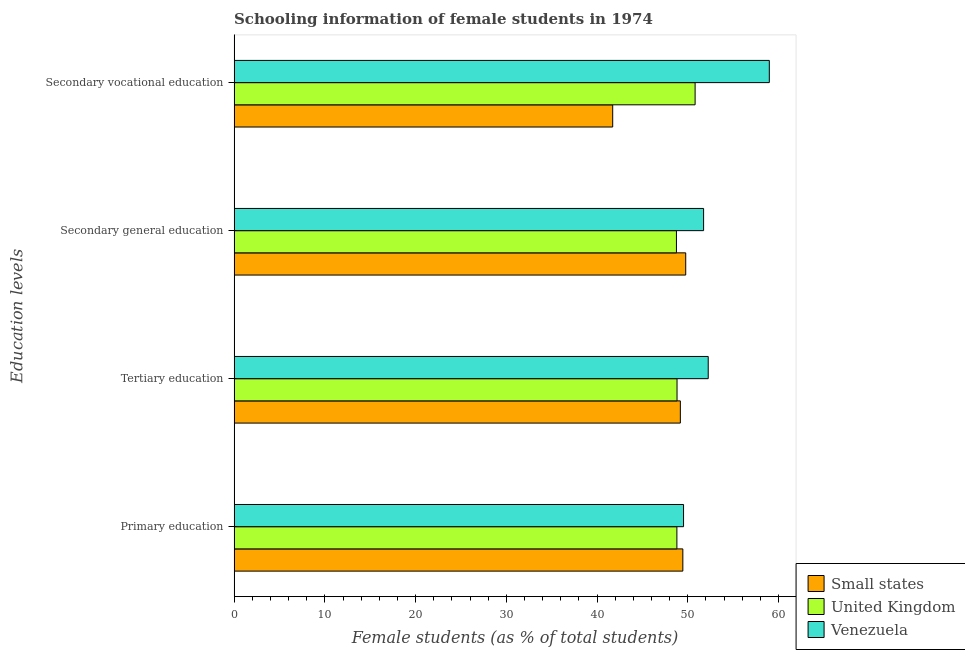Are the number of bars per tick equal to the number of legend labels?
Your response must be concise. Yes. Are the number of bars on each tick of the Y-axis equal?
Ensure brevity in your answer.  Yes. How many bars are there on the 4th tick from the bottom?
Make the answer very short. 3. What is the label of the 2nd group of bars from the top?
Your answer should be very brief. Secondary general education. What is the percentage of female students in primary education in United Kingdom?
Give a very brief answer. 48.8. Across all countries, what is the maximum percentage of female students in primary education?
Offer a very short reply. 49.53. Across all countries, what is the minimum percentage of female students in primary education?
Give a very brief answer. 48.8. In which country was the percentage of female students in secondary education maximum?
Keep it short and to the point. Venezuela. In which country was the percentage of female students in secondary education minimum?
Provide a succinct answer. United Kingdom. What is the total percentage of female students in tertiary education in the graph?
Your answer should be very brief. 150.25. What is the difference between the percentage of female students in primary education in Venezuela and that in Small states?
Provide a succinct answer. 0.08. What is the difference between the percentage of female students in tertiary education in Small states and the percentage of female students in secondary education in Venezuela?
Provide a succinct answer. -2.56. What is the average percentage of female students in secondary vocational education per country?
Keep it short and to the point. 50.51. What is the difference between the percentage of female students in secondary education and percentage of female students in tertiary education in Small states?
Your answer should be compact. 0.59. What is the ratio of the percentage of female students in secondary education in United Kingdom to that in Small states?
Your response must be concise. 0.98. Is the percentage of female students in tertiary education in United Kingdom less than that in Venezuela?
Provide a short and direct response. Yes. Is the difference between the percentage of female students in secondary vocational education in Small states and United Kingdom greater than the difference between the percentage of female students in primary education in Small states and United Kingdom?
Keep it short and to the point. No. What is the difference between the highest and the second highest percentage of female students in secondary vocational education?
Provide a short and direct response. 8.18. What is the difference between the highest and the lowest percentage of female students in secondary vocational education?
Keep it short and to the point. 17.26. Is it the case that in every country, the sum of the percentage of female students in tertiary education and percentage of female students in secondary vocational education is greater than the sum of percentage of female students in secondary education and percentage of female students in primary education?
Your response must be concise. No. What does the 2nd bar from the top in Secondary general education represents?
Provide a short and direct response. United Kingdom. How many bars are there?
Provide a succinct answer. 12. Are all the bars in the graph horizontal?
Your answer should be compact. Yes. Does the graph contain any zero values?
Ensure brevity in your answer.  No. Where does the legend appear in the graph?
Provide a short and direct response. Bottom right. How many legend labels are there?
Your response must be concise. 3. What is the title of the graph?
Offer a very short reply. Schooling information of female students in 1974. Does "Dominica" appear as one of the legend labels in the graph?
Offer a terse response. No. What is the label or title of the X-axis?
Give a very brief answer. Female students (as % of total students). What is the label or title of the Y-axis?
Your response must be concise. Education levels. What is the Female students (as % of total students) of Small states in Primary education?
Give a very brief answer. 49.46. What is the Female students (as % of total students) in United Kingdom in Primary education?
Make the answer very short. 48.8. What is the Female students (as % of total students) of Venezuela in Primary education?
Offer a very short reply. 49.53. What is the Female students (as % of total students) of Small states in Tertiary education?
Your response must be concise. 49.18. What is the Female students (as % of total students) in United Kingdom in Tertiary education?
Give a very brief answer. 48.82. What is the Female students (as % of total students) of Venezuela in Tertiary education?
Provide a succinct answer. 52.25. What is the Female students (as % of total students) of Small states in Secondary general education?
Make the answer very short. 49.77. What is the Female students (as % of total students) in United Kingdom in Secondary general education?
Offer a very short reply. 48.75. What is the Female students (as % of total students) of Venezuela in Secondary general education?
Make the answer very short. 51.74. What is the Female students (as % of total students) of Small states in Secondary vocational education?
Your response must be concise. 41.73. What is the Female students (as % of total students) of United Kingdom in Secondary vocational education?
Provide a succinct answer. 50.81. What is the Female students (as % of total students) in Venezuela in Secondary vocational education?
Provide a succinct answer. 58.99. Across all Education levels, what is the maximum Female students (as % of total students) of Small states?
Ensure brevity in your answer.  49.77. Across all Education levels, what is the maximum Female students (as % of total students) of United Kingdom?
Make the answer very short. 50.81. Across all Education levels, what is the maximum Female students (as % of total students) of Venezuela?
Make the answer very short. 58.99. Across all Education levels, what is the minimum Female students (as % of total students) in Small states?
Your response must be concise. 41.73. Across all Education levels, what is the minimum Female students (as % of total students) in United Kingdom?
Ensure brevity in your answer.  48.75. Across all Education levels, what is the minimum Female students (as % of total students) in Venezuela?
Keep it short and to the point. 49.53. What is the total Female students (as % of total students) in Small states in the graph?
Provide a succinct answer. 190.13. What is the total Female students (as % of total students) in United Kingdom in the graph?
Your response must be concise. 197.17. What is the total Female students (as % of total students) of Venezuela in the graph?
Provide a short and direct response. 212.51. What is the difference between the Female students (as % of total students) in Small states in Primary education and that in Tertiary education?
Your answer should be very brief. 0.28. What is the difference between the Female students (as % of total students) in United Kingdom in Primary education and that in Tertiary education?
Make the answer very short. -0.02. What is the difference between the Female students (as % of total students) in Venezuela in Primary education and that in Tertiary education?
Make the answer very short. -2.72. What is the difference between the Female students (as % of total students) in Small states in Primary education and that in Secondary general education?
Make the answer very short. -0.32. What is the difference between the Female students (as % of total students) of United Kingdom in Primary education and that in Secondary general education?
Make the answer very short. 0.05. What is the difference between the Female students (as % of total students) in Venezuela in Primary education and that in Secondary general education?
Your answer should be very brief. -2.21. What is the difference between the Female students (as % of total students) of Small states in Primary education and that in Secondary vocational education?
Keep it short and to the point. 7.73. What is the difference between the Female students (as % of total students) in United Kingdom in Primary education and that in Secondary vocational education?
Provide a short and direct response. -2.01. What is the difference between the Female students (as % of total students) of Venezuela in Primary education and that in Secondary vocational education?
Your answer should be compact. -9.45. What is the difference between the Female students (as % of total students) of Small states in Tertiary education and that in Secondary general education?
Provide a succinct answer. -0.59. What is the difference between the Female students (as % of total students) of United Kingdom in Tertiary education and that in Secondary general education?
Make the answer very short. 0.07. What is the difference between the Female students (as % of total students) in Venezuela in Tertiary education and that in Secondary general education?
Your response must be concise. 0.51. What is the difference between the Female students (as % of total students) of Small states in Tertiary education and that in Secondary vocational education?
Your answer should be compact. 7.45. What is the difference between the Female students (as % of total students) in United Kingdom in Tertiary education and that in Secondary vocational education?
Ensure brevity in your answer.  -1.99. What is the difference between the Female students (as % of total students) in Venezuela in Tertiary education and that in Secondary vocational education?
Provide a short and direct response. -6.73. What is the difference between the Female students (as % of total students) of Small states in Secondary general education and that in Secondary vocational education?
Your answer should be very brief. 8.05. What is the difference between the Female students (as % of total students) in United Kingdom in Secondary general education and that in Secondary vocational education?
Provide a short and direct response. -2.06. What is the difference between the Female students (as % of total students) of Venezuela in Secondary general education and that in Secondary vocational education?
Provide a short and direct response. -7.24. What is the difference between the Female students (as % of total students) of Small states in Primary education and the Female students (as % of total students) of United Kingdom in Tertiary education?
Provide a succinct answer. 0.64. What is the difference between the Female students (as % of total students) of Small states in Primary education and the Female students (as % of total students) of Venezuela in Tertiary education?
Your response must be concise. -2.8. What is the difference between the Female students (as % of total students) of United Kingdom in Primary education and the Female students (as % of total students) of Venezuela in Tertiary education?
Ensure brevity in your answer.  -3.45. What is the difference between the Female students (as % of total students) in Small states in Primary education and the Female students (as % of total students) in United Kingdom in Secondary general education?
Your answer should be very brief. 0.71. What is the difference between the Female students (as % of total students) of Small states in Primary education and the Female students (as % of total students) of Venezuela in Secondary general education?
Ensure brevity in your answer.  -2.29. What is the difference between the Female students (as % of total students) in United Kingdom in Primary education and the Female students (as % of total students) in Venezuela in Secondary general education?
Make the answer very short. -2.94. What is the difference between the Female students (as % of total students) in Small states in Primary education and the Female students (as % of total students) in United Kingdom in Secondary vocational education?
Your answer should be compact. -1.35. What is the difference between the Female students (as % of total students) in Small states in Primary education and the Female students (as % of total students) in Venezuela in Secondary vocational education?
Ensure brevity in your answer.  -9.53. What is the difference between the Female students (as % of total students) of United Kingdom in Primary education and the Female students (as % of total students) of Venezuela in Secondary vocational education?
Offer a terse response. -10.19. What is the difference between the Female students (as % of total students) of Small states in Tertiary education and the Female students (as % of total students) of United Kingdom in Secondary general education?
Your answer should be very brief. 0.43. What is the difference between the Female students (as % of total students) of Small states in Tertiary education and the Female students (as % of total students) of Venezuela in Secondary general education?
Ensure brevity in your answer.  -2.56. What is the difference between the Female students (as % of total students) of United Kingdom in Tertiary education and the Female students (as % of total students) of Venezuela in Secondary general education?
Keep it short and to the point. -2.93. What is the difference between the Female students (as % of total students) in Small states in Tertiary education and the Female students (as % of total students) in United Kingdom in Secondary vocational education?
Provide a short and direct response. -1.63. What is the difference between the Female students (as % of total students) of Small states in Tertiary education and the Female students (as % of total students) of Venezuela in Secondary vocational education?
Your answer should be compact. -9.81. What is the difference between the Female students (as % of total students) in United Kingdom in Tertiary education and the Female students (as % of total students) in Venezuela in Secondary vocational education?
Your answer should be compact. -10.17. What is the difference between the Female students (as % of total students) in Small states in Secondary general education and the Female students (as % of total students) in United Kingdom in Secondary vocational education?
Give a very brief answer. -1.04. What is the difference between the Female students (as % of total students) of Small states in Secondary general education and the Female students (as % of total students) of Venezuela in Secondary vocational education?
Provide a succinct answer. -9.21. What is the difference between the Female students (as % of total students) of United Kingdom in Secondary general education and the Female students (as % of total students) of Venezuela in Secondary vocational education?
Keep it short and to the point. -10.24. What is the average Female students (as % of total students) in Small states per Education levels?
Offer a terse response. 47.53. What is the average Female students (as % of total students) in United Kingdom per Education levels?
Keep it short and to the point. 49.29. What is the average Female students (as % of total students) of Venezuela per Education levels?
Keep it short and to the point. 53.13. What is the difference between the Female students (as % of total students) in Small states and Female students (as % of total students) in United Kingdom in Primary education?
Provide a succinct answer. 0.66. What is the difference between the Female students (as % of total students) of Small states and Female students (as % of total students) of Venezuela in Primary education?
Give a very brief answer. -0.08. What is the difference between the Female students (as % of total students) of United Kingdom and Female students (as % of total students) of Venezuela in Primary education?
Offer a very short reply. -0.73. What is the difference between the Female students (as % of total students) in Small states and Female students (as % of total students) in United Kingdom in Tertiary education?
Provide a short and direct response. 0.36. What is the difference between the Female students (as % of total students) in Small states and Female students (as % of total students) in Venezuela in Tertiary education?
Provide a succinct answer. -3.07. What is the difference between the Female students (as % of total students) of United Kingdom and Female students (as % of total students) of Venezuela in Tertiary education?
Your response must be concise. -3.44. What is the difference between the Female students (as % of total students) in Small states and Female students (as % of total students) in United Kingdom in Secondary general education?
Provide a succinct answer. 1.02. What is the difference between the Female students (as % of total students) of Small states and Female students (as % of total students) of Venezuela in Secondary general education?
Provide a short and direct response. -1.97. What is the difference between the Female students (as % of total students) in United Kingdom and Female students (as % of total students) in Venezuela in Secondary general education?
Give a very brief answer. -2.99. What is the difference between the Female students (as % of total students) of Small states and Female students (as % of total students) of United Kingdom in Secondary vocational education?
Provide a short and direct response. -9.08. What is the difference between the Female students (as % of total students) of Small states and Female students (as % of total students) of Venezuela in Secondary vocational education?
Your answer should be very brief. -17.26. What is the difference between the Female students (as % of total students) in United Kingdom and Female students (as % of total students) in Venezuela in Secondary vocational education?
Offer a terse response. -8.18. What is the ratio of the Female students (as % of total students) of Small states in Primary education to that in Tertiary education?
Ensure brevity in your answer.  1.01. What is the ratio of the Female students (as % of total students) of Venezuela in Primary education to that in Tertiary education?
Your answer should be very brief. 0.95. What is the ratio of the Female students (as % of total students) in Venezuela in Primary education to that in Secondary general education?
Give a very brief answer. 0.96. What is the ratio of the Female students (as % of total students) in Small states in Primary education to that in Secondary vocational education?
Your response must be concise. 1.19. What is the ratio of the Female students (as % of total students) of United Kingdom in Primary education to that in Secondary vocational education?
Keep it short and to the point. 0.96. What is the ratio of the Female students (as % of total students) of Venezuela in Primary education to that in Secondary vocational education?
Your answer should be compact. 0.84. What is the ratio of the Female students (as % of total students) of Small states in Tertiary education to that in Secondary general education?
Provide a succinct answer. 0.99. What is the ratio of the Female students (as % of total students) in United Kingdom in Tertiary education to that in Secondary general education?
Make the answer very short. 1. What is the ratio of the Female students (as % of total students) in Venezuela in Tertiary education to that in Secondary general education?
Your response must be concise. 1.01. What is the ratio of the Female students (as % of total students) of Small states in Tertiary education to that in Secondary vocational education?
Offer a very short reply. 1.18. What is the ratio of the Female students (as % of total students) in United Kingdom in Tertiary education to that in Secondary vocational education?
Offer a terse response. 0.96. What is the ratio of the Female students (as % of total students) in Venezuela in Tertiary education to that in Secondary vocational education?
Keep it short and to the point. 0.89. What is the ratio of the Female students (as % of total students) of Small states in Secondary general education to that in Secondary vocational education?
Make the answer very short. 1.19. What is the ratio of the Female students (as % of total students) of United Kingdom in Secondary general education to that in Secondary vocational education?
Keep it short and to the point. 0.96. What is the ratio of the Female students (as % of total students) in Venezuela in Secondary general education to that in Secondary vocational education?
Provide a short and direct response. 0.88. What is the difference between the highest and the second highest Female students (as % of total students) in Small states?
Your answer should be compact. 0.32. What is the difference between the highest and the second highest Female students (as % of total students) of United Kingdom?
Keep it short and to the point. 1.99. What is the difference between the highest and the second highest Female students (as % of total students) in Venezuela?
Offer a terse response. 6.73. What is the difference between the highest and the lowest Female students (as % of total students) in Small states?
Offer a very short reply. 8.05. What is the difference between the highest and the lowest Female students (as % of total students) of United Kingdom?
Provide a short and direct response. 2.06. What is the difference between the highest and the lowest Female students (as % of total students) of Venezuela?
Keep it short and to the point. 9.45. 